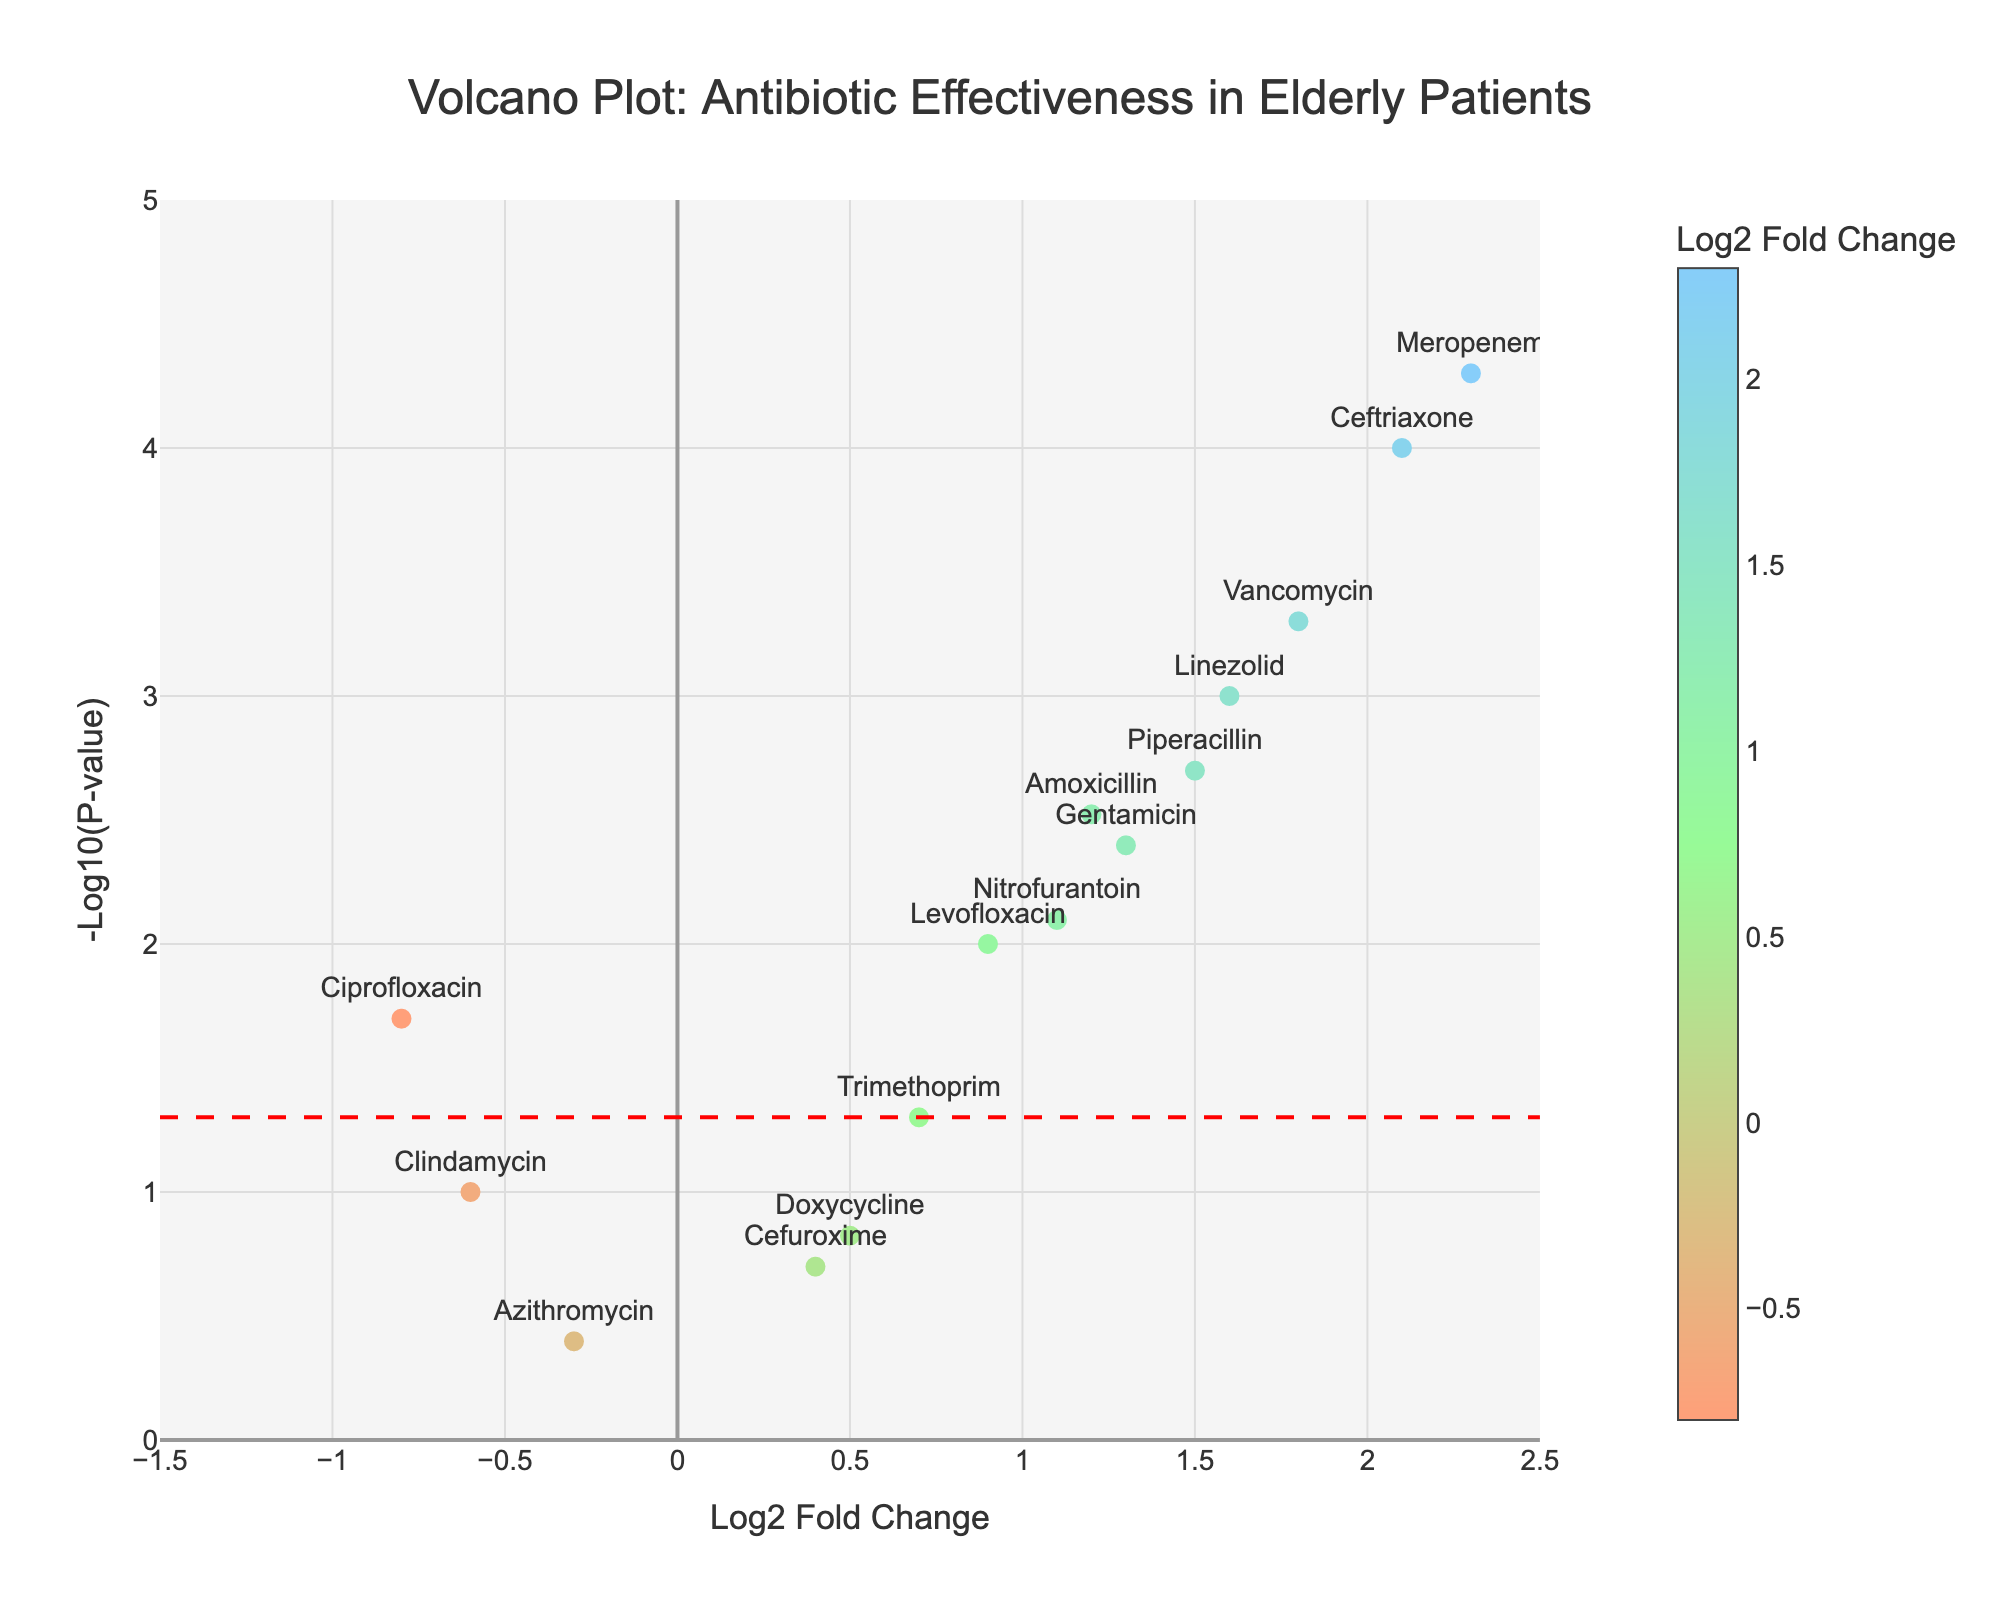What is the title of the plot? The title is usually positioned at the top center of the plot. In this case, it reads: "Volcano Plot: Antibiotic Effectiveness in Elderly Patients."
Answer: Volcano Plot: Antibiotic Effectiveness in Elderly Patients How many antibiotics have a p-value less than 0.05? To find the number, look for data points above the horizontal significance line at -log10(0.05). Count all these points.
Answer: 10 Which antibiotic has the highest log2 fold change? Look for the data point farthest to the right on the x-axis. The highest log2 fold change is marked by Ceftriaxone.
Answer: Ceftriaxone What is the log2 fold change for Ciprofloxacin? Locate Ciprofloxacin (Pneumonia) on the plot. The x-axis value or log2 fold change for Ciprofloxacin is -0.8.
Answer: -0.8 Which infections have antibiotics with log2 fold change greater than 1 and a p-value less than 0.01? Identify points to the right of log2 fold change = 1 and above -log10(0.01) on the plot. The infections are Sepsis (Ceftriaxone, Meropenem) and MRSA (Vancomycin).
Answer: Sepsis and MRSA Which antibiotic has the lowest p-value? Find the data point highest on the y-axis, indicating the most significant -log10(p-value). Here, Meropenem has the lowest p-value.
Answer: Meropenem How many antibiotics have a negative log2 fold change? Count the data points to the left of the log2 fold change = 0 line on the x-axis. There are 3 antibiotics: Ciprofloxacin, Azithromycin, and Clindamycin.
Answer: 3 Which infection does Piperacillin treat, and is it statistically significant (p-value < 0.05)? Find Piperacillin on the plot and note the infection it treats (Pneumonia). Check if its corresponding point is above the significance line. Piperacillin treats Pneumonia and is statistically significant.
Answer: Pneumonia, yes Which antibiotic has a log2 fold change of approximately 1.3 and what is the corresponding p-value? Look for the point around log2 fold change of 1.3 on the x-axis and match it with the corresponding antibiotic (Gentamicin). The p-value for Gentamicin is 0.004.
Answer: Gentamicin, 0.004 